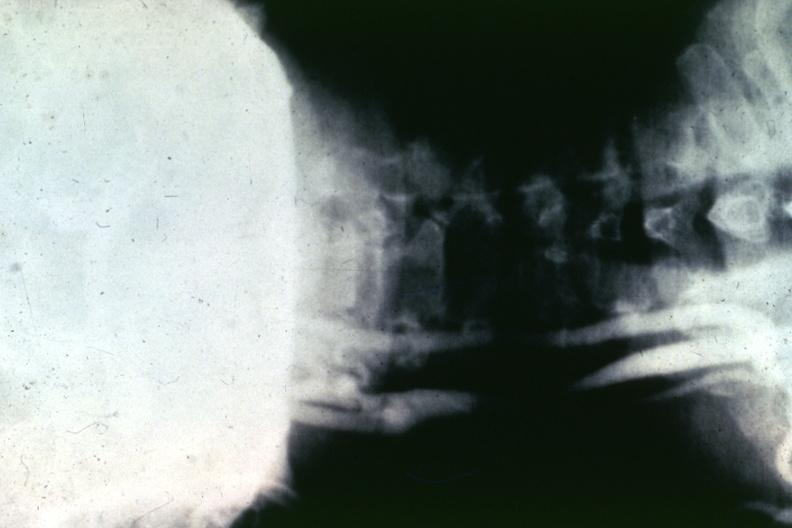where is this from?
Answer the question using a single word or phrase. Vasculature 